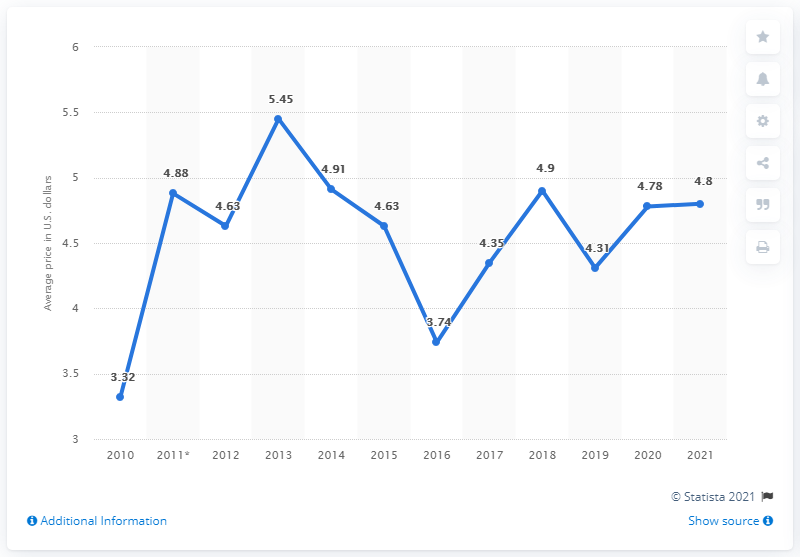Indicate a few pertinent items in this graphic. The average price for a Big Mac burger in Uruguay in January 2021 was approximately 4.8 USD. 